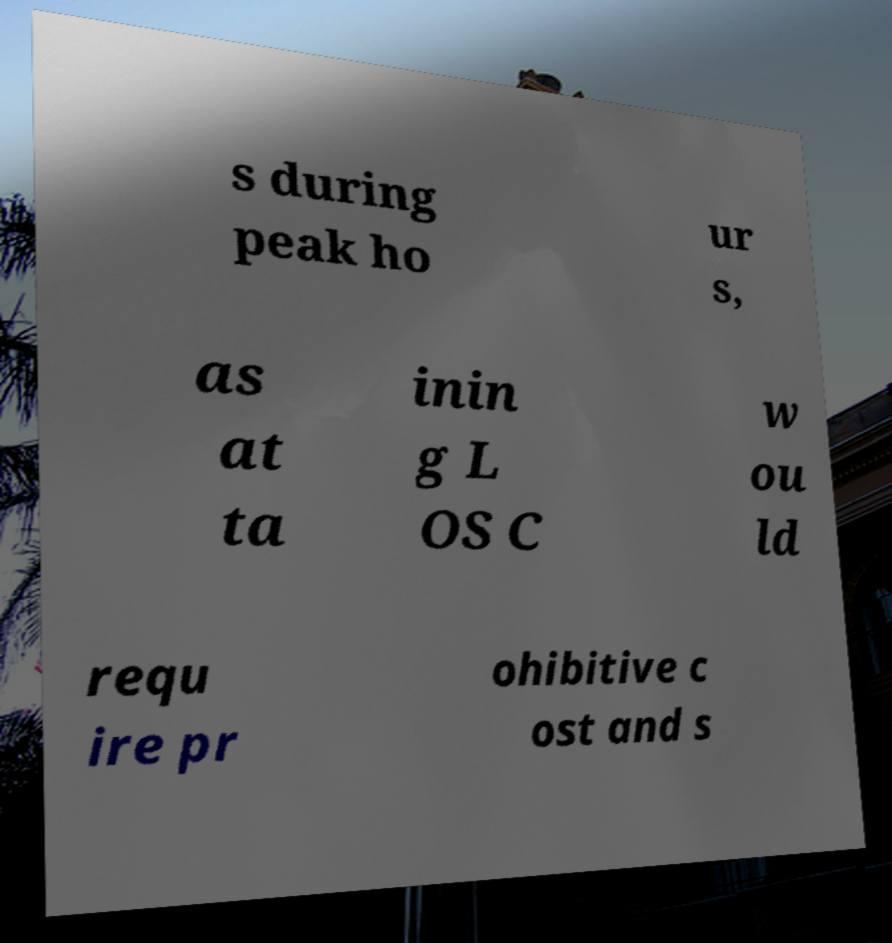Please read and relay the text visible in this image. What does it say? s during peak ho ur s, as at ta inin g L OS C w ou ld requ ire pr ohibitive c ost and s 